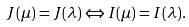Convert formula to latex. <formula><loc_0><loc_0><loc_500><loc_500>J ( \mu ) = J ( \lambda ) \Leftrightarrow I ( \mu ) = I ( \lambda ) .</formula> 